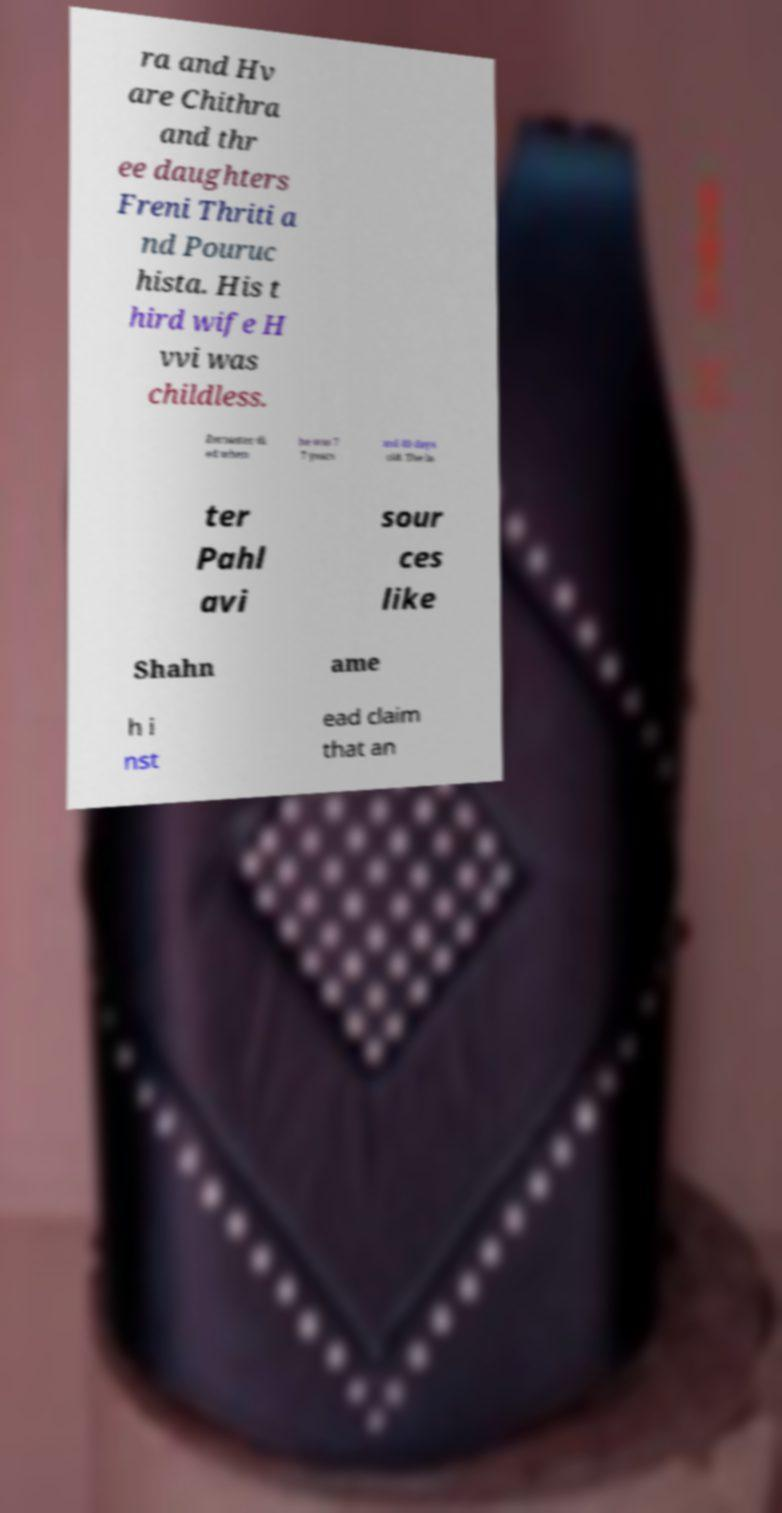What messages or text are displayed in this image? I need them in a readable, typed format. ra and Hv are Chithra and thr ee daughters Freni Thriti a nd Pouruc hista. His t hird wife H vvi was childless. Zoroaster di ed when he was 7 7 years and 40 days old. The la ter Pahl avi sour ces like Shahn ame h i nst ead claim that an 